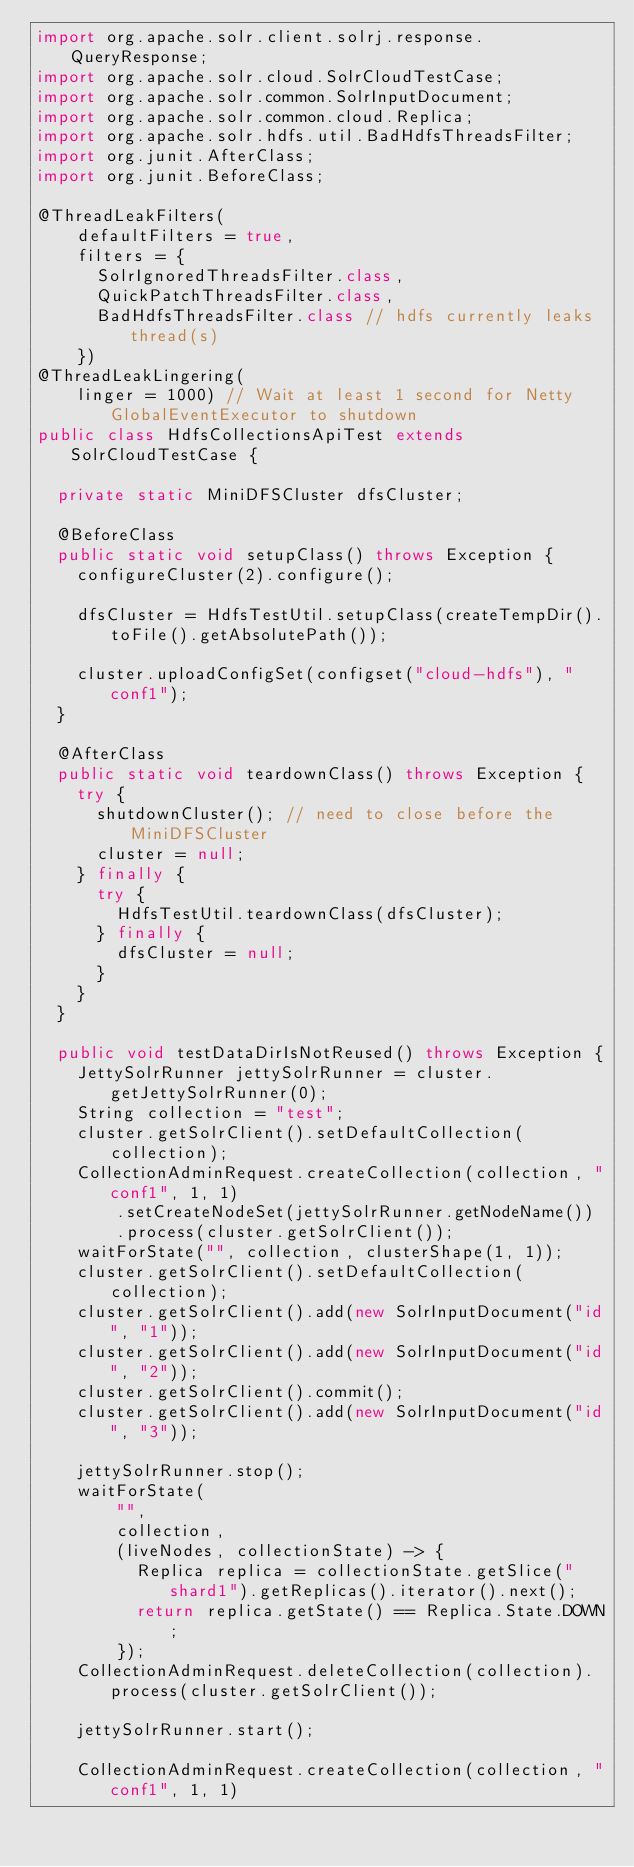Convert code to text. <code><loc_0><loc_0><loc_500><loc_500><_Java_>import org.apache.solr.client.solrj.response.QueryResponse;
import org.apache.solr.cloud.SolrCloudTestCase;
import org.apache.solr.common.SolrInputDocument;
import org.apache.solr.common.cloud.Replica;
import org.apache.solr.hdfs.util.BadHdfsThreadsFilter;
import org.junit.AfterClass;
import org.junit.BeforeClass;

@ThreadLeakFilters(
    defaultFilters = true,
    filters = {
      SolrIgnoredThreadsFilter.class,
      QuickPatchThreadsFilter.class,
      BadHdfsThreadsFilter.class // hdfs currently leaks thread(s)
    })
@ThreadLeakLingering(
    linger = 1000) // Wait at least 1 second for Netty GlobalEventExecutor to shutdown
public class HdfsCollectionsApiTest extends SolrCloudTestCase {

  private static MiniDFSCluster dfsCluster;

  @BeforeClass
  public static void setupClass() throws Exception {
    configureCluster(2).configure();

    dfsCluster = HdfsTestUtil.setupClass(createTempDir().toFile().getAbsolutePath());

    cluster.uploadConfigSet(configset("cloud-hdfs"), "conf1");
  }

  @AfterClass
  public static void teardownClass() throws Exception {
    try {
      shutdownCluster(); // need to close before the MiniDFSCluster
      cluster = null;
    } finally {
      try {
        HdfsTestUtil.teardownClass(dfsCluster);
      } finally {
        dfsCluster = null;
      }
    }
  }

  public void testDataDirIsNotReused() throws Exception {
    JettySolrRunner jettySolrRunner = cluster.getJettySolrRunner(0);
    String collection = "test";
    cluster.getSolrClient().setDefaultCollection(collection);
    CollectionAdminRequest.createCollection(collection, "conf1", 1, 1)
        .setCreateNodeSet(jettySolrRunner.getNodeName())
        .process(cluster.getSolrClient());
    waitForState("", collection, clusterShape(1, 1));
    cluster.getSolrClient().setDefaultCollection(collection);
    cluster.getSolrClient().add(new SolrInputDocument("id", "1"));
    cluster.getSolrClient().add(new SolrInputDocument("id", "2"));
    cluster.getSolrClient().commit();
    cluster.getSolrClient().add(new SolrInputDocument("id", "3"));

    jettySolrRunner.stop();
    waitForState(
        "",
        collection,
        (liveNodes, collectionState) -> {
          Replica replica = collectionState.getSlice("shard1").getReplicas().iterator().next();
          return replica.getState() == Replica.State.DOWN;
        });
    CollectionAdminRequest.deleteCollection(collection).process(cluster.getSolrClient());

    jettySolrRunner.start();

    CollectionAdminRequest.createCollection(collection, "conf1", 1, 1)</code> 